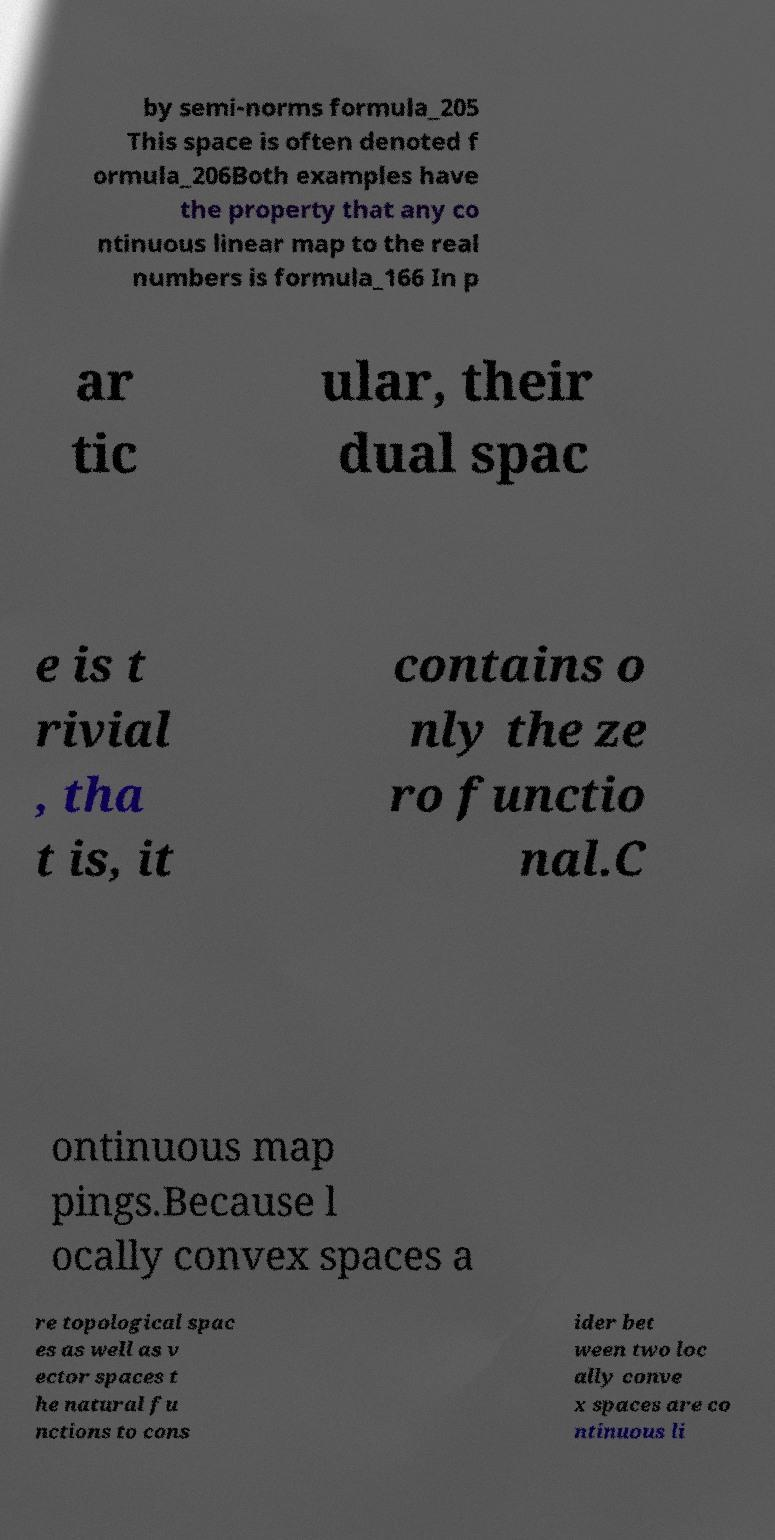Can you accurately transcribe the text from the provided image for me? by semi-norms formula_205 This space is often denoted f ormula_206Both examples have the property that any co ntinuous linear map to the real numbers is formula_166 In p ar tic ular, their dual spac e is t rivial , tha t is, it contains o nly the ze ro functio nal.C ontinuous map pings.Because l ocally convex spaces a re topological spac es as well as v ector spaces t he natural fu nctions to cons ider bet ween two loc ally conve x spaces are co ntinuous li 